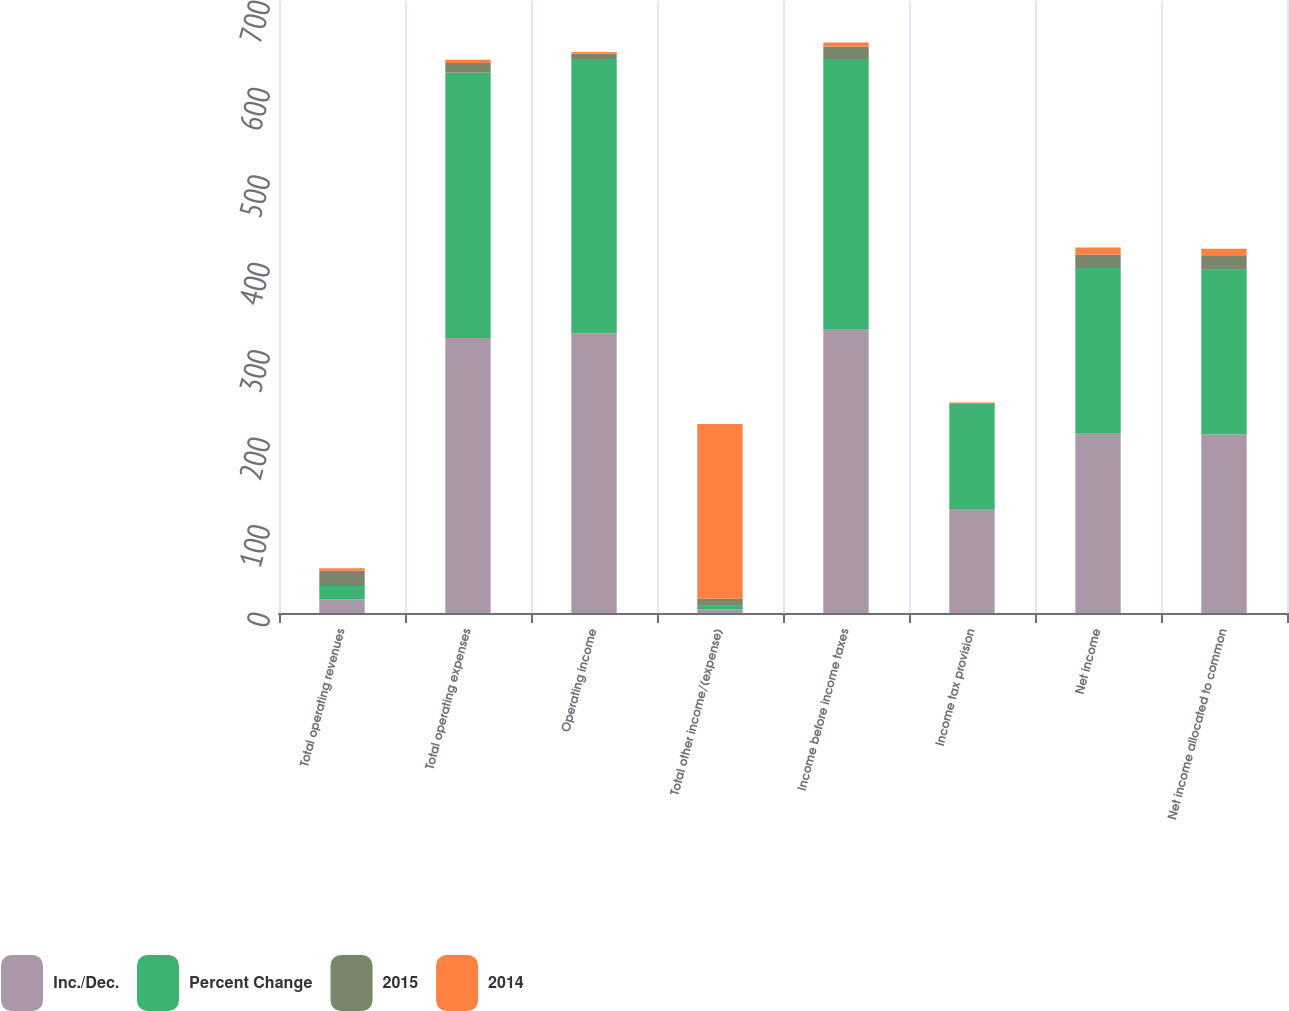<chart> <loc_0><loc_0><loc_500><loc_500><stacked_bar_chart><ecel><fcel>Total operating revenues<fcel>Total operating expenses<fcel>Operating income<fcel>Total other income/(expense)<fcel>Income before income taxes<fcel>Income tax provision<fcel>Net income<fcel>Net income allocated to common<nl><fcel>Inc./Dec.<fcel>15.5<fcel>314.6<fcel>319.9<fcel>4.1<fcel>324<fcel>119<fcel>205<fcel>204.1<nl><fcel>Percent Change<fcel>15.5<fcel>303.4<fcel>313.8<fcel>4.1<fcel>309.7<fcel>120<fcel>189.7<fcel>188.4<nl><fcel>2015<fcel>17.3<fcel>11.2<fcel>6.1<fcel>8.2<fcel>14.3<fcel>1<fcel>15.3<fcel>15.7<nl><fcel>2014<fcel>2.8<fcel>3.7<fcel>1.9<fcel>199.8<fcel>4.6<fcel>0.8<fcel>8.1<fcel>8.4<nl></chart> 